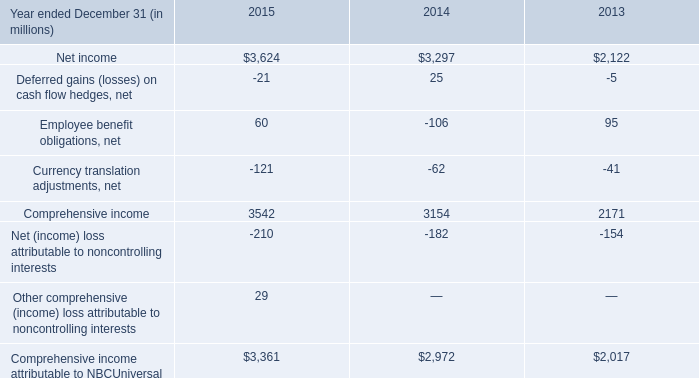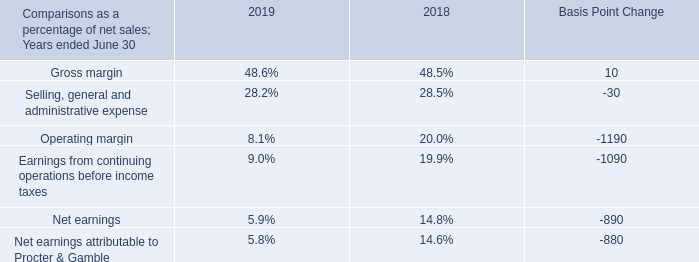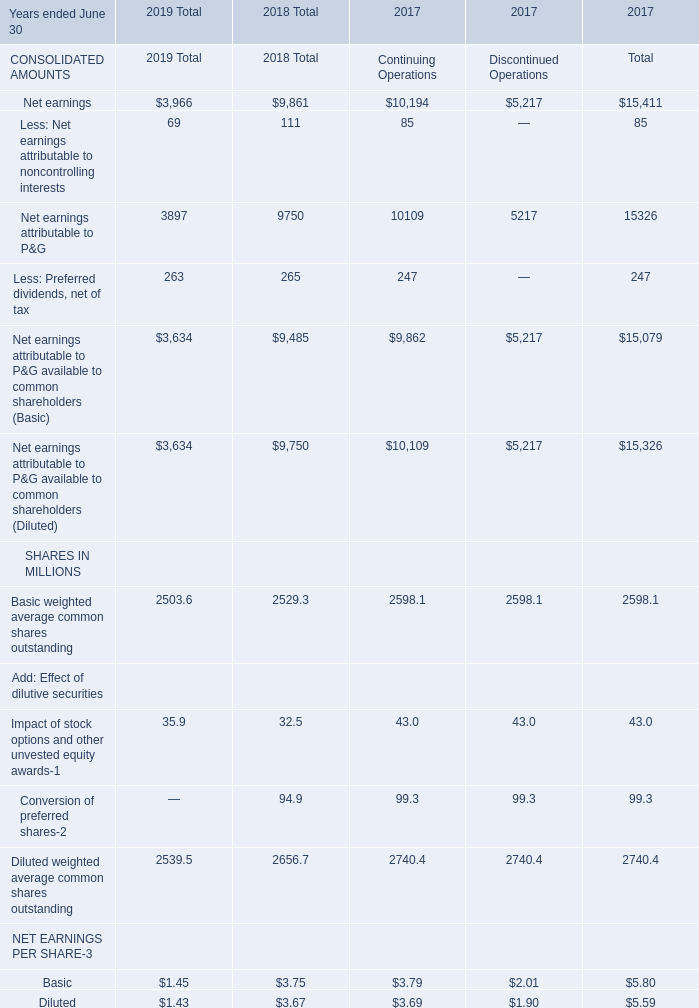What was the total amount of the Net earnings in the years where Net earnings is greater than 1 
Computations: ((((3966 + 9861) + 10194) + 5217) + 15411)
Answer: 44649.0. 